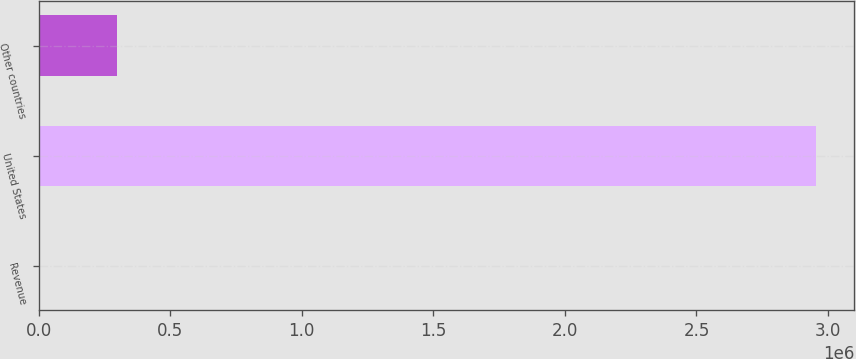Convert chart to OTSL. <chart><loc_0><loc_0><loc_500><loc_500><bar_chart><fcel>Revenue<fcel>United States<fcel>Other countries<nl><fcel>2011<fcel>2.95262e+06<fcel>297072<nl></chart> 